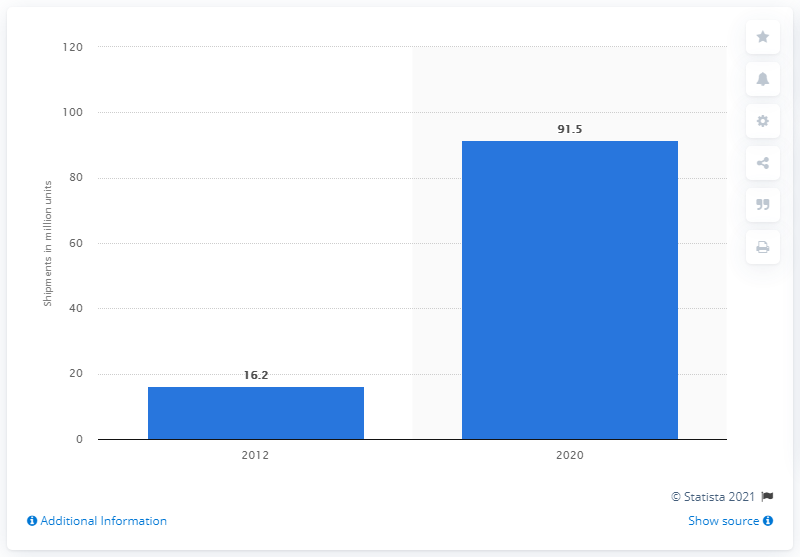Mention a couple of crucial points in this snapshot. The global shipment of ADAS units is expected to reach 91.5 units by 2020. 